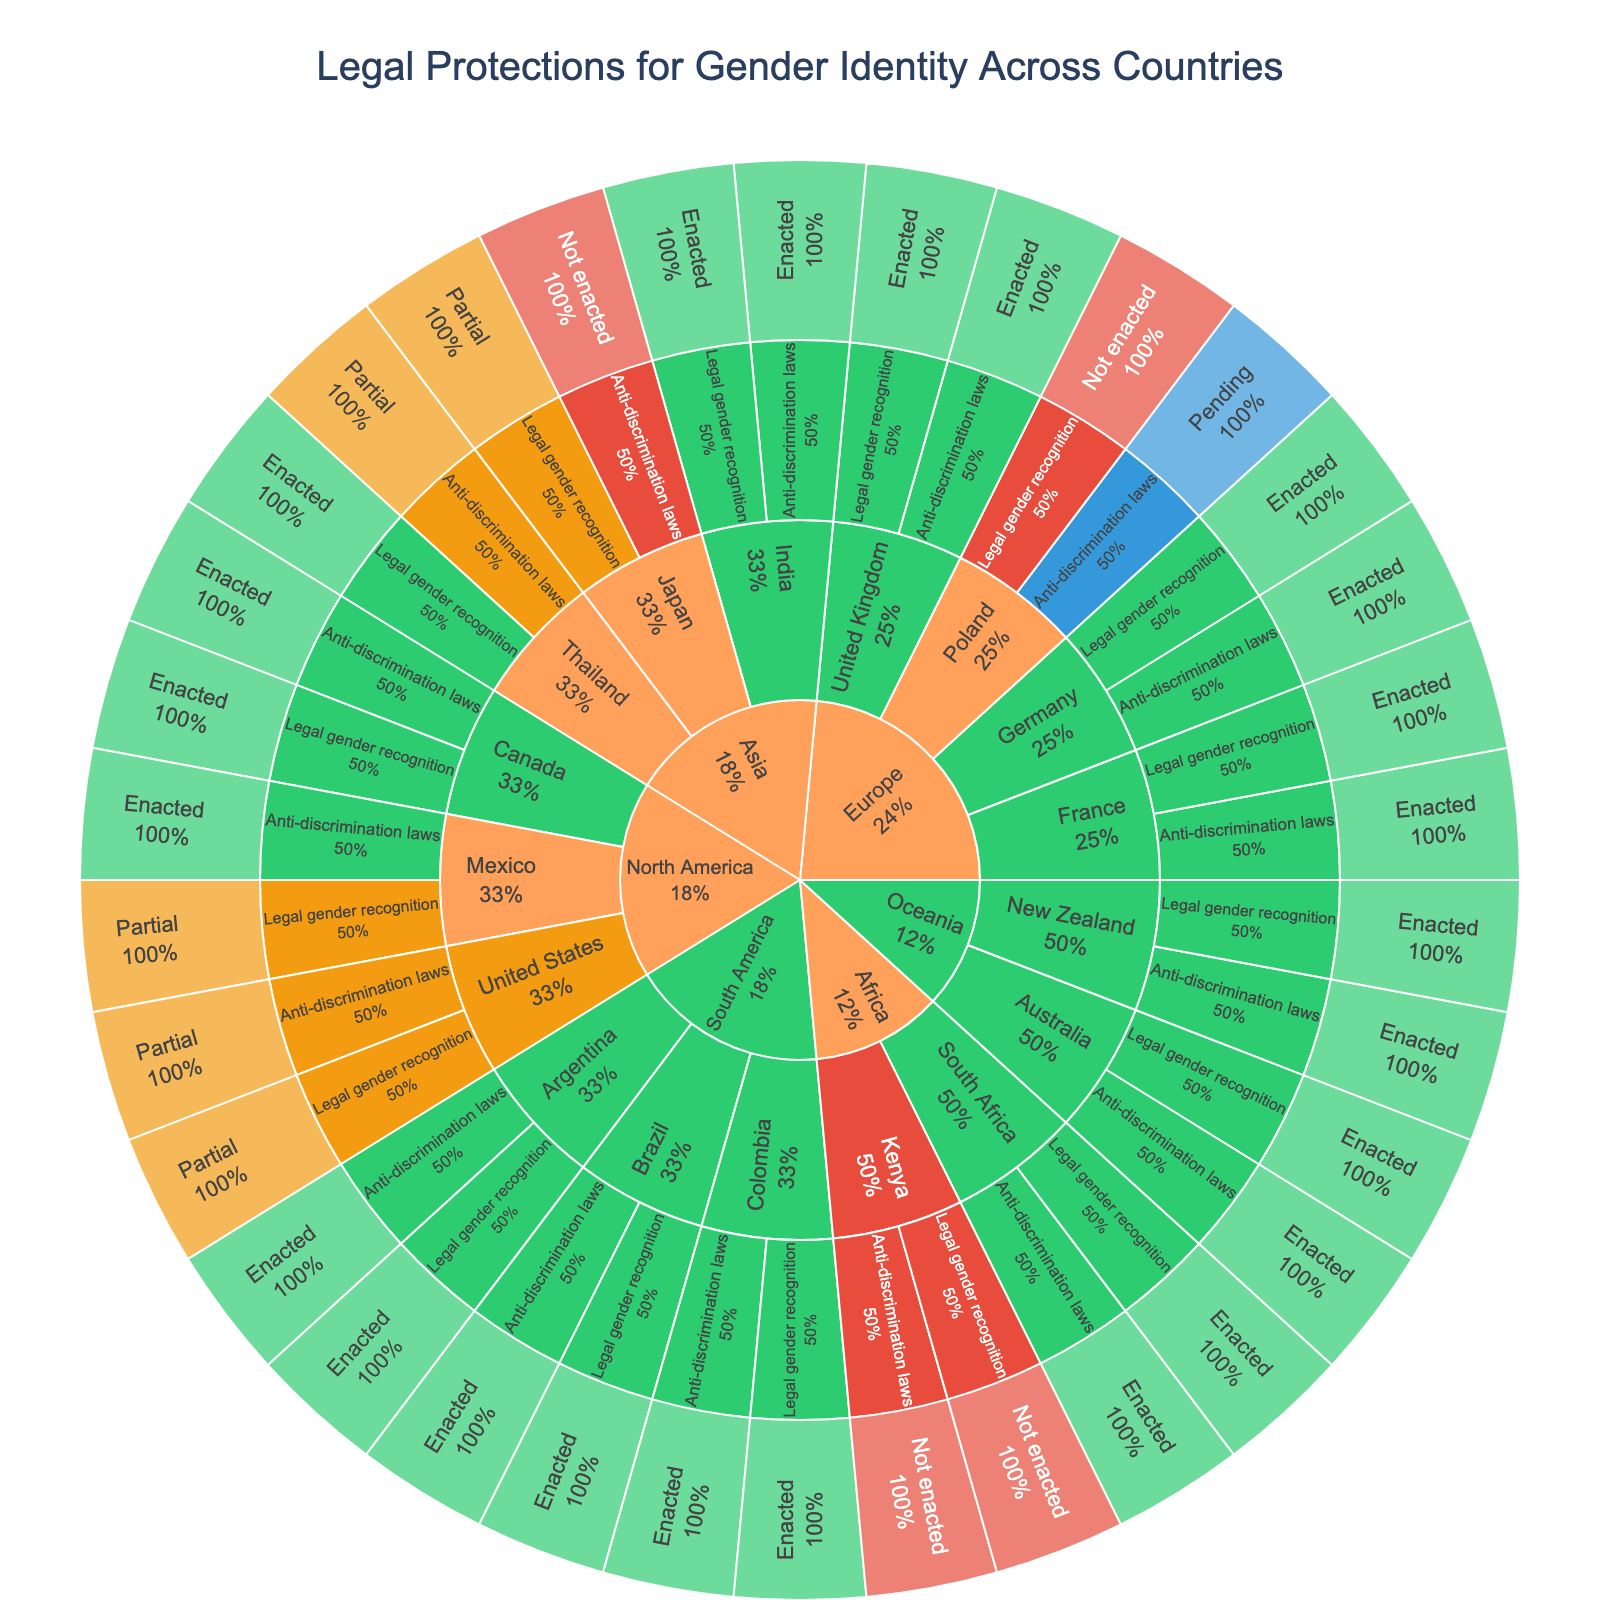What is the title of the sunburst plot? The title is prominently displayed at the top of the plot and helps to identify the main subject of the visualization. The element labeled "Legal Protections for Gender Identity Across Countries" in the figure is the title.
Answer: Legal Protections for Gender Identity Across Countries Which region has the most enacted legal protections for gender identity? By visually inspecting the segments within the sunburst plot, the larger green segments (indicating "Enacted" status) clustered in certain regions help identify which region has the most enacted protections. The majority of the green segments are in Europe and South America.
Answer: Europe How many general protection types are represented in the plot? Each country within a region has segments categorized by "protection_type" which are Anti-discrimination laws and Legal gender recognition. Thus, there are 2 general protection types.
Answer: 2 Which country in North America has only partial protections for gender identity? The sunburst plot shows different countries and their protection types with segments colored by status. "Partial" status is indicated by a specific color, looking for partially colored segments in North America identifies that the United States has partial protections.
Answer: United States How many countries in Asia have "Enacted" legal gender recognition protections? By identifying the inner segments for the region 'Asia' and inspecting the final segments that show 'Legal gender recognition' with 'Enacted' status, we count the countries having this specific protection. Japan has partial, India and Thailand have enacted. Thus, countries having 'Enacted' legal gender protections in Asia are India and Thailand.
Answer: 2 Which protection type in Oceania does not have any "Not enacted" status? By looking at Oceania region in the sunburst plot and checking the status colors for both "Anti-discrimination laws" and "Legal gender recognition," one can see that none of the segments within Oceania have a red color indicating "Not enacted" protections for either type.
Answer: Both Is there any country in the data with "Pending" status for legal protections? By scanning the colors representing protection statuses across different regions, 'Pending' is indicated by a blue color. The region Europe has Poland with Pending status for Anti-discrimination laws
Answer: Yes, Poland Compare the enacted protections between South America and Africa regions. How do they differ? Both regions can be inspected for the green segments indicating enacted protections. South America has all three countries (Brazil, Argentina, Colombia) with both types of protections enacted, whereas the Africa region has mixed statuses with South Africa having green in both but Kenya having none.
Answer: South America is more consistent in enacted protections Which country in the data has the maximum different levels of protection status? The sunburst plot shows multiple statuses across different countries; we look for a country that has "Enacted," "Partial," and "Not enacted." By combining and comparing segments featuring different protection statuses, the United States has two types both partially enacted.
Answer: The United States How is the protection status distributed in Europe for the 'Legal gender recognition' type? By checking the segments under Europe for the 'Legal gender recognition' type, one can classify the statuses of 'Enacted,' 'Not enacted,' and otherwise. United Kingdom, France, and Germany have enacted, while Poland has not enacted.
Answer: Mostly enacted, except Poland 